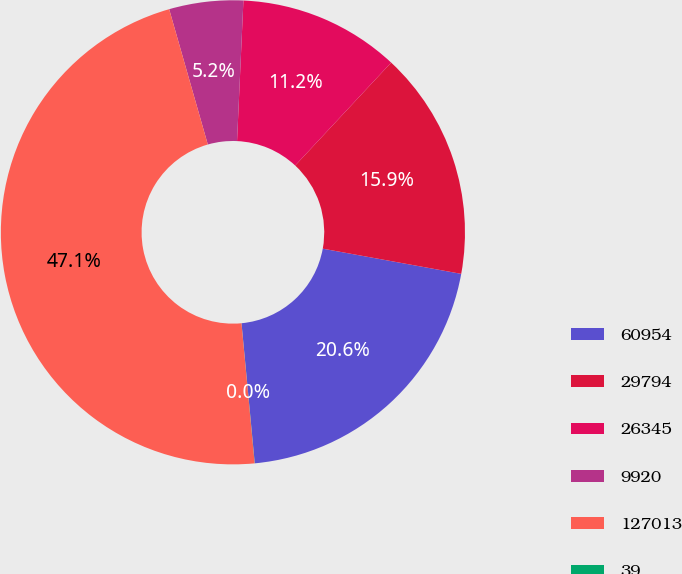<chart> <loc_0><loc_0><loc_500><loc_500><pie_chart><fcel>60954<fcel>29794<fcel>26345<fcel>9920<fcel>127013<fcel>39<nl><fcel>20.63%<fcel>15.92%<fcel>11.22%<fcel>5.15%<fcel>47.06%<fcel>0.01%<nl></chart> 